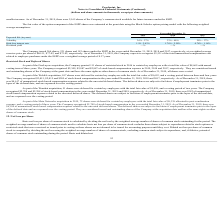From Proofpoint's financial document, What is the expected life (in years) of the option component of the ESPP shares in each of the years ended December 31, 2019? The document contains multiple relevant values: 0.5, 0.5, 0.5. From the document: "Expected life (in years) 0.5 0.5 0.5..." Also, What is the number of shares issued in the years ended December 31, 2017 to 2019 respectively? The document contains multiple relevant values: $73.02, $77.02, $86.51. From the document: "exercise price per share of $86.51, $77.02, and $73.02, respectively. As of December 31, 2019, the Company expects to recognize $3,531 of the total un..." Also, What is the total unamortized compensation cost related to employee purchases under the ESPP the company expects to recognise as of December 31, 2019? According to the financial document, $3,531. The relevant text states: "ecember 31, 2019, the Company expects to recognize $3,531 of the total unamortized compensation cost related to employee purchases under the ESPP over a weigh..." Also, can you calculate: What is the percentage change in the total unamortized compensation cost related to employee purchases under the ESPP the company expects to recognise between 2018 and 2019? To answer this question, I need to perform calculations using the financial data. The calculation is: (86.51 - 77.02)/77.02 , which equals 12.32 (percentage). This is based on the information: "exercise price per share of $86.51, $77.02, and $73.02, respectively. As of December 31, 2019, the Company expects to recognize $3,531 of the exercise price per share of $86.51, $77.02, and $73.02, re..." The key data points involved are: 77.02, 86.51. Also, can you calculate: What is the total shares issued under the ESPP between December 2017 to 2019? Based on the calculation: 266 + 231 + 183 , the result is 680. This is based on the information: "The Company issued 266 shares, 231 shares and 183 shares under the ESPP in the years ended December 31, 2019, 2018 and 2017, respectively, at a weigh The Company issued 266 shares, 231 shares and 183 ..." The key data points involved are: 183, 231, 266. Also, can you calculate: What is the average volatility of the fair value of the option component of the ESPP shares as at December 31, 2019? To answer this question, I need to perform calculations using the financial data. The calculation is: (36% + 37%)/2 , which equals 36.5 (percentage). This is based on the information: "Volatility 36% - 37% 33% - 40% 29% - 37% Volatility 36% - 37% 33% - 40% 29% - 37% Volatility 36% - 37% 33% - 40% 29% - 37%..." The key data points involved are: 2, 37. 